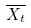Convert formula to latex. <formula><loc_0><loc_0><loc_500><loc_500>\overline { X _ { t } }</formula> 